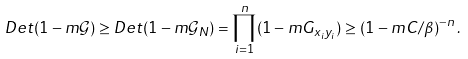<formula> <loc_0><loc_0><loc_500><loc_500>D e t ( 1 - m \mathcal { G } ) \geq D e t ( 1 - m \mathcal { G } _ { N } ) = \prod _ { i = 1 } ^ { n } ( 1 - m G _ { x _ { i } y _ { i } } ) \geq ( 1 - m C / \beta ) ^ { - n } \, .</formula> 